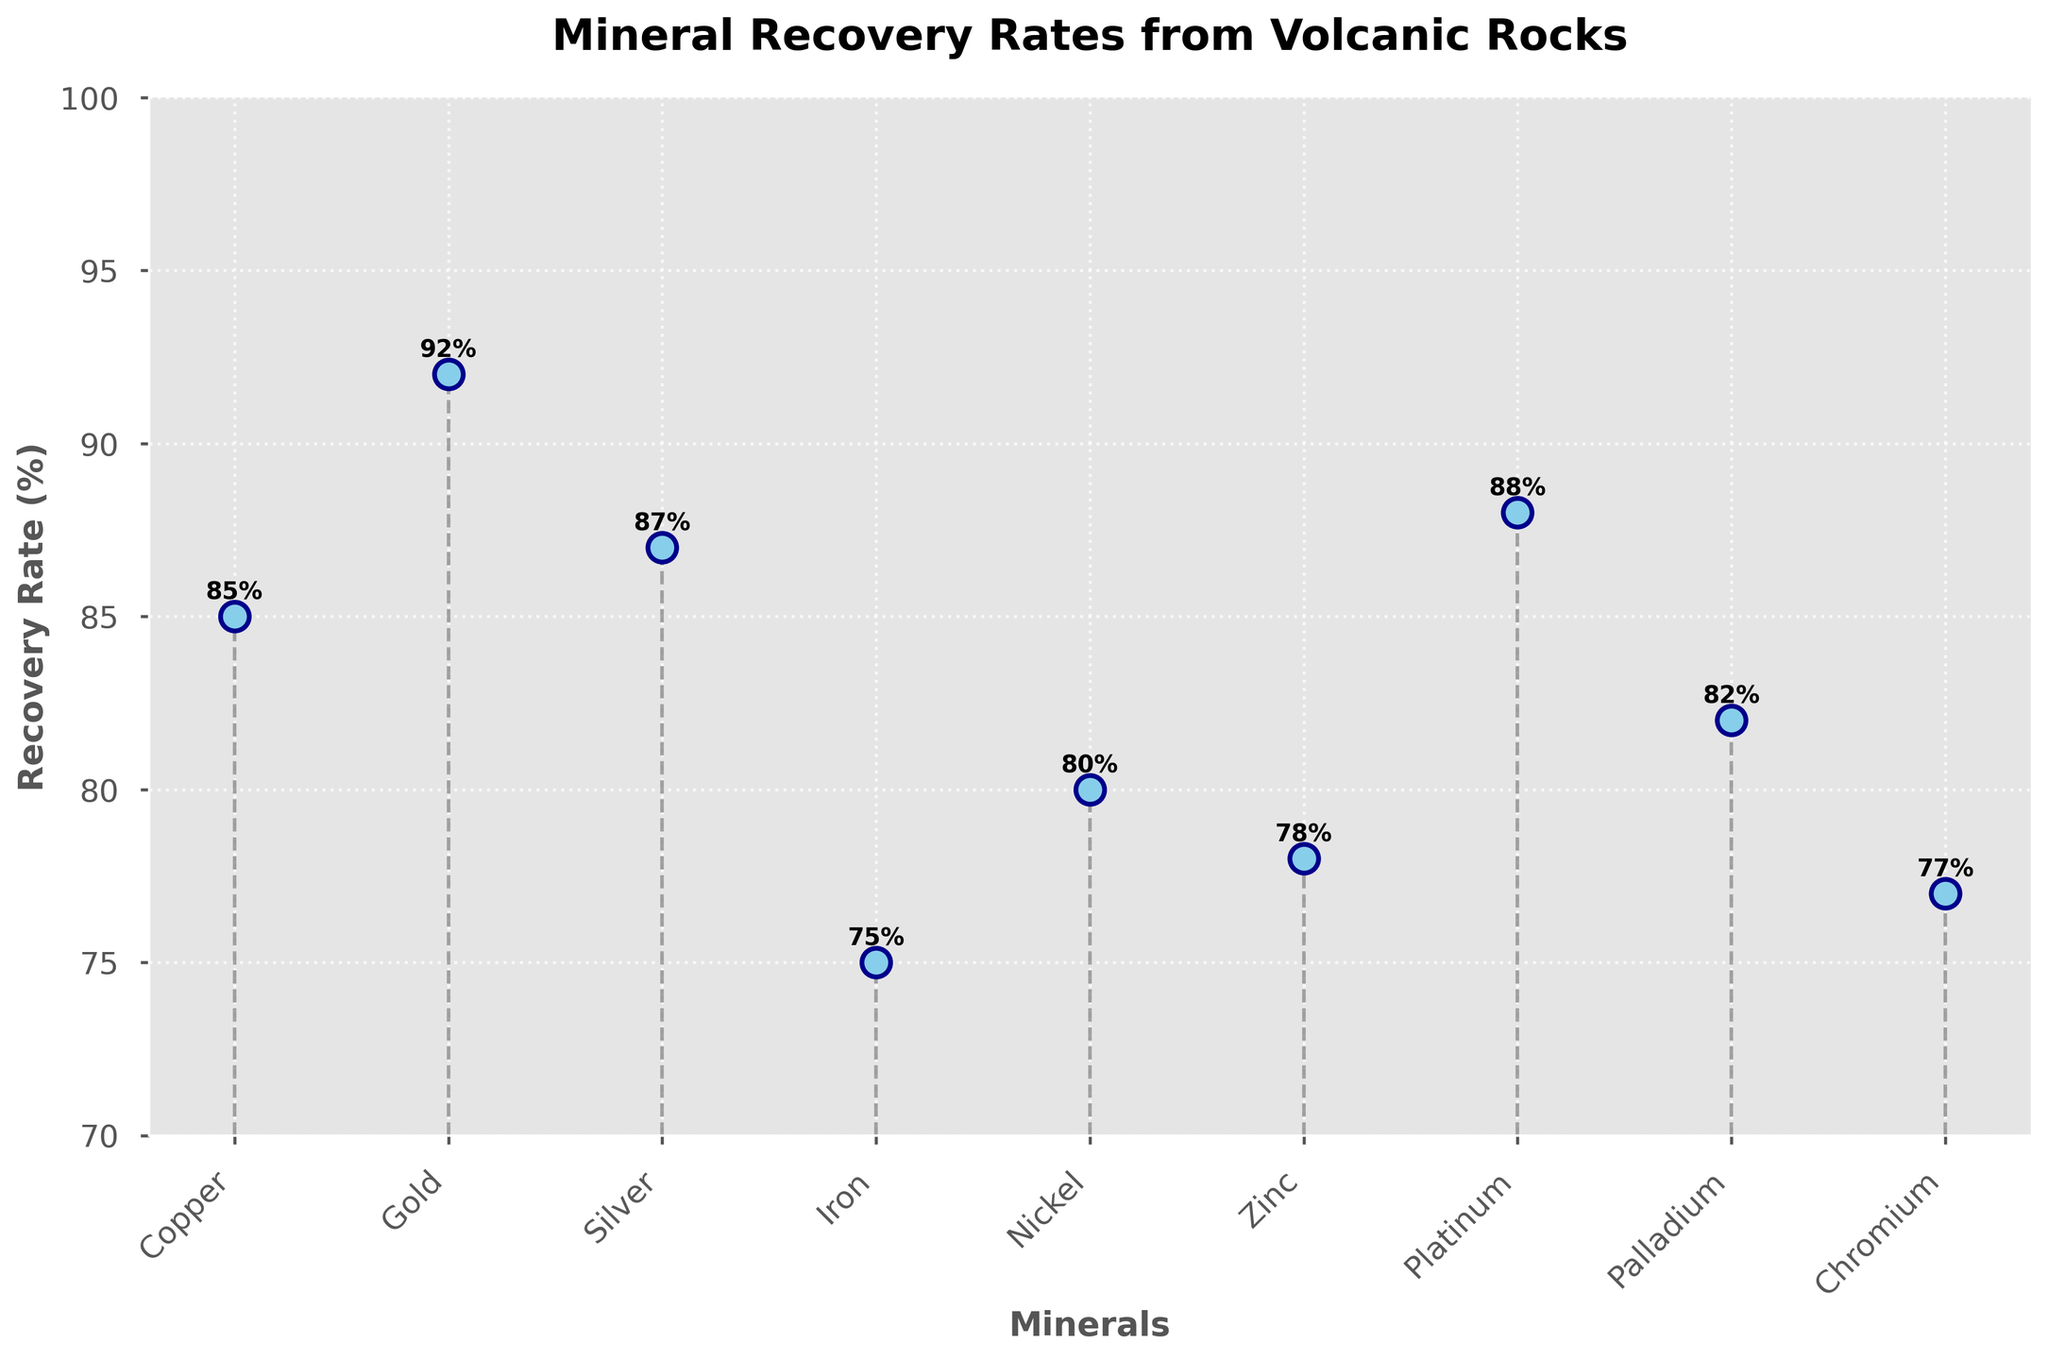Which mineral has the highest recovery rate? The mineral with the highest recovery rate is determined by looking at the highest point on the y-axis. The highest recovery rate among the minerals is 92%.
Answer: Gold What is the average recovery rate of all the minerals? To find the average recovery rate, sum all recovery rates and divide by the number of minerals. Sum = 85 + 92 + 87 + 75 + 80 + 78 + 88 + 82 + 77 = 744; Number of minerals = 9; Average = 744 / 9 ≈ 82.67
Answer: 82.67 Which mineral has the lowest recovery rate? The mineral with the lowest recovery rate is determined by looking at the lowest point on the y-axis. The lowest recovery rate among the minerals is 75%.
Answer: Iron How many minerals have a recovery rate above 85%? Count the number of minerals with a recovery rate greater than 85%: Copper (85%), Gold (92%), Silver (87%), Platinum (88%).
Answer: 4 What is the difference in recovery rates between Gold and Iron? Subtract the recovery rate of Iron from the recovery rate of Gold: 92% (Gold) - 75% (Iron) = 17%
Answer: 17 How much higher is the recovery rate of Palladium compared to Zinc? Subtract the recovery rate of Zinc from that of Palladium: 82% (Palladium) - 78% (Zinc) = 4%
Answer: 4 What is the median recovery rate of the minerals? Arrange the recovery rates in ascending order and find the middle value: 75, 77, 78, 80, 82, 85, 87, 88, 92. The median is the middle value of this ordered list, which is 82%.
Answer: 82 Which minerals have recovery rates between 80% and 90%? Identify minerals with recovery rates within the specified range: Silver (87%), Platinum (88%), Palladium (82%), Copper (85%).
Answer: Silver, Platinum, Palladium, Copper Which two minerals have the closest recovery rates? Compare the differences between recovery rates to find the smallest difference: 82% (Palladium) - 80% (Nickel) = 2%. The smallest difference is 2% between Nickel and Palladium.
Answer: Nickel and Palladium What is the range of recovery rates shown in the plot? The range is the difference between the highest and lowest recovery rates: 92% (Gold) - 75% (Iron) = 17%.
Answer: 17 